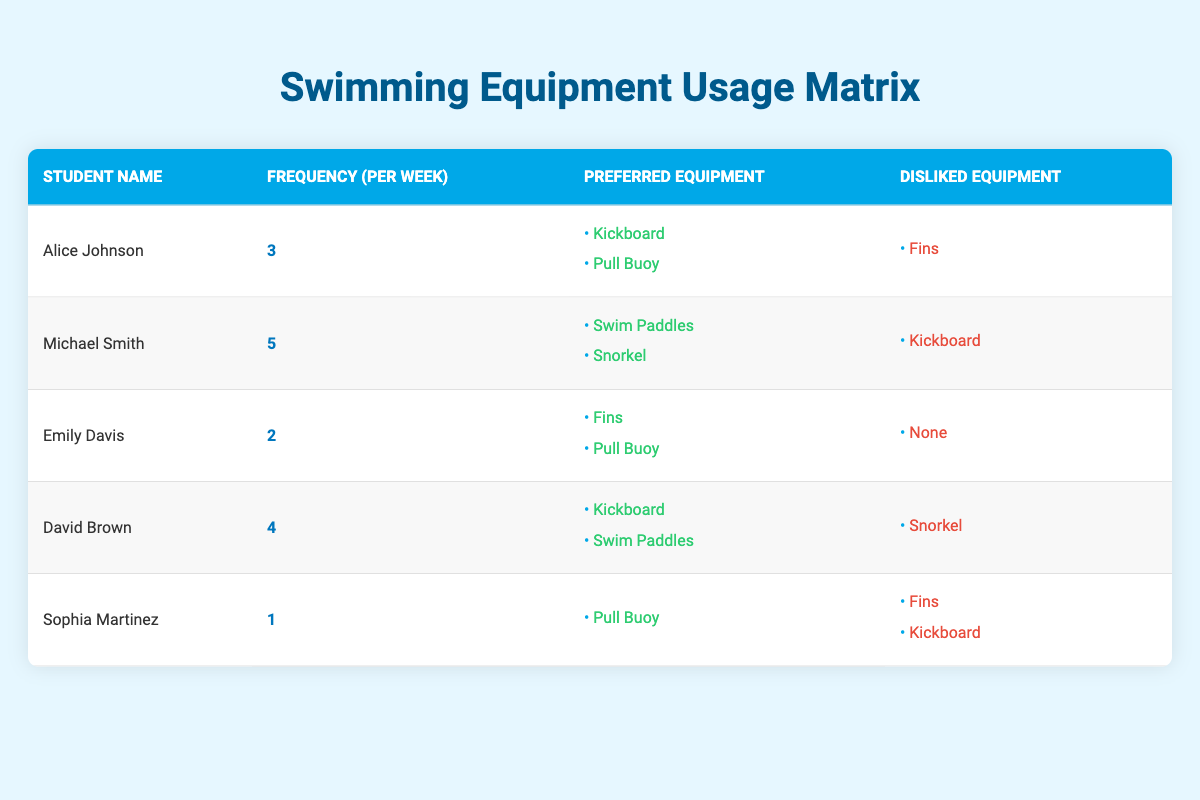What is the most preferred equipment among all students? To find the most preferred equipment, we look at the "Preferred Equipment" column for each student. The equipment listed is Kickboard (3 preferences), Pull Buoy (4 preferences), Swim Paddles (2 preferences), Snorkel (2 preferences), and Fins (2 preferences). The Pull Buoy is preferred by the highest number of students, so it is the most preferred equipment.
Answer: Pull Buoy Which student dislikes the Kickboard? Referring to the "Disliked Equipment" column, Alice Johnson and Michael Smith both dislike the Kickboard.
Answer: Alice Johnson and Michael Smith What is the total frequency of usage per week for all students? We sum up the "Frequency (per week)" values from all students: 3 (Alice) + 5 (Michael) + 2 (Emily) + 4 (David) + 1 (Sophia) = 15.
Answer: 15 Is there any student who dislikes the Fins? Looking at the "Disliked Equipment" column, Alice Johnson, Sophia Martinez, and David Brown dislike the Fins. Hence, there are students who dislike this equipment.
Answer: Yes Which student has the highest frequency of swimming practice? By examining the "Frequency (per week)" column, Michael Smith has the highest frequency at 5.
Answer: Michael Smith How many students prefer Swim Paddles? In the "Preferred Equipment" column, Swim Paddles are preferred by David Brown and Michael Smith. Counting these, 2 students prefer Swim Paddles.
Answer: 2 What equipment do Sophia Martinez and Emily Davis have in common? In the "Preferred Equipment" column, Sophia prefers Pull Buoy, while Emily also prefers Fins and Pull Buoy. The common equipment between them is Pull Buoy.
Answer: Pull Buoy What is the average frequency of equipment usage among all students? To find the average frequency, sum the usage frequencies: 3 + 5 + 2 + 4 + 1 = 15, and divide by the number of students (5): 15/5 = 3.
Answer: 3 Does any student dislike both Fins and Kickboard? Looking into the "Disliked Equipment" column, Sophia Martinez dislikes both Fins and Kickboard. So, the answer is yes.
Answer: Yes 